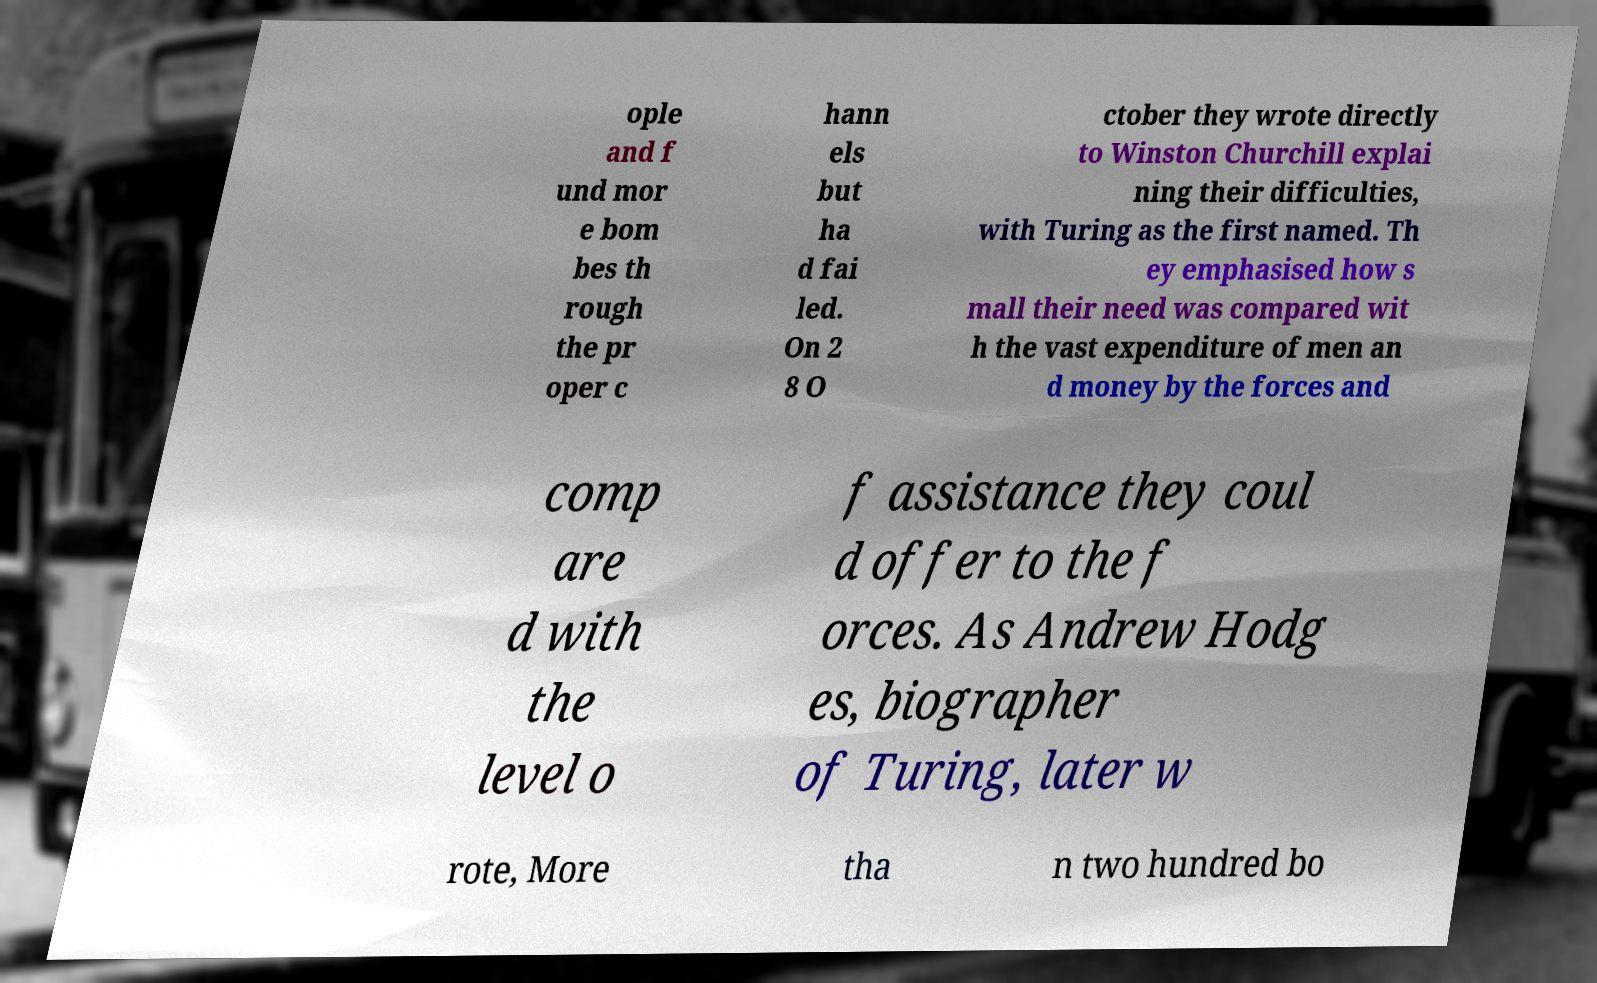Could you assist in decoding the text presented in this image and type it out clearly? ople and f und mor e bom bes th rough the pr oper c hann els but ha d fai led. On 2 8 O ctober they wrote directly to Winston Churchill explai ning their difficulties, with Turing as the first named. Th ey emphasised how s mall their need was compared wit h the vast expenditure of men an d money by the forces and comp are d with the level o f assistance they coul d offer to the f orces. As Andrew Hodg es, biographer of Turing, later w rote, More tha n two hundred bo 